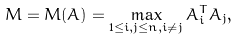<formula> <loc_0><loc_0><loc_500><loc_500>M = M ( A ) = \max _ { 1 \leq i , j \leq n , i \neq j } A _ { i } ^ { T } A _ { j } ,</formula> 